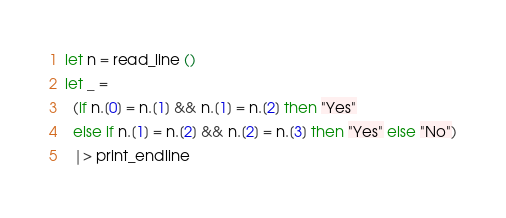<code> <loc_0><loc_0><loc_500><loc_500><_OCaml_>let n = read_line ()
let _ =
  (if n.[0] = n.[1] && n.[1] = n.[2] then "Yes"
  else if n.[1] = n.[2] && n.[2] = n.[3] then "Yes" else "No")
  |> print_endline</code> 